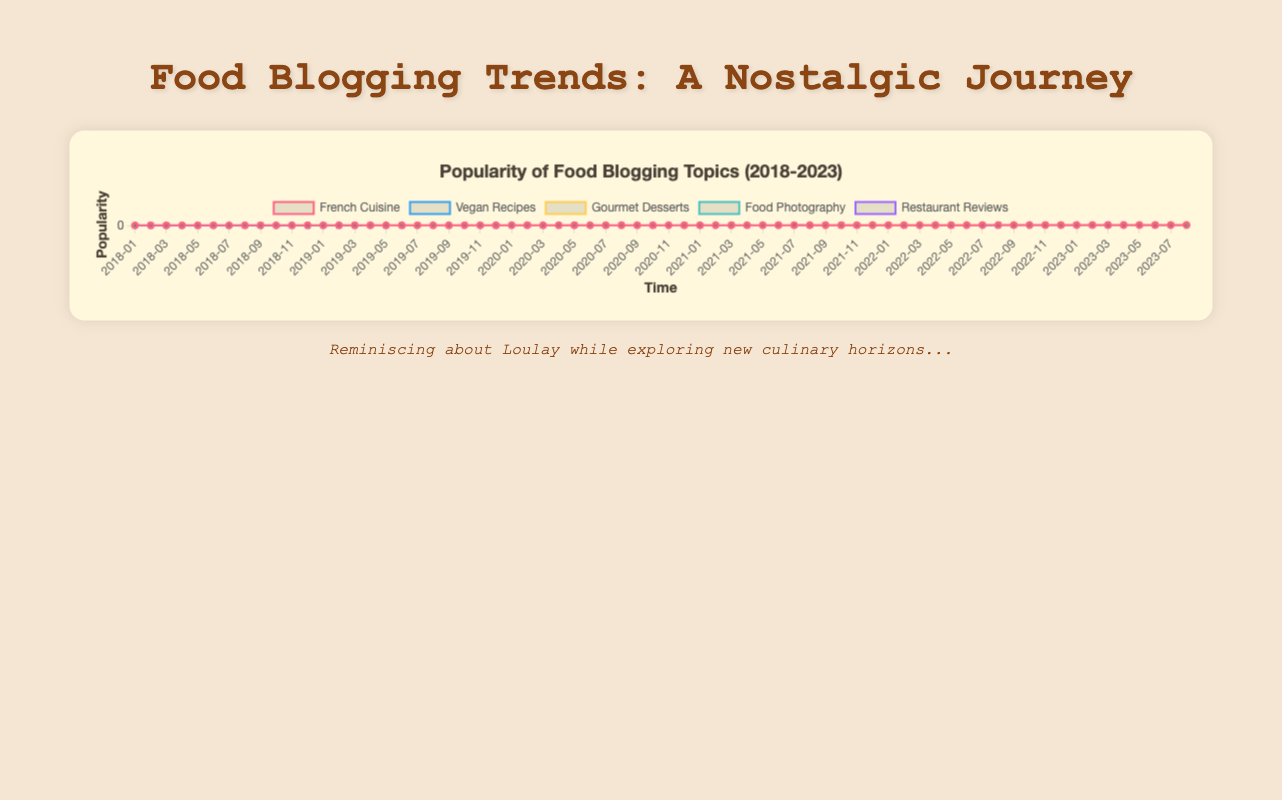What is the trend of "French Cuisine" popularity from January 2018 to August 2023? The "French Cuisine" popularity shows a general upward trend from January 2018 to August 2023. In January 2018, it starts at 45 and increases to 162 by August 2023.
Answer: Upward Which food blogging topic had the highest popularity in August 2023? In August 2023, "Restaurant Reviews" had the highest popularity with a value of 204.
Answer: Restaurant Reviews Between "Vegan Recipes" and "Gourmet Desserts," which topic had a higher surge in popularity from January 2020 to January 2021? For "Vegan Recipes," the popularity increased from 85 in January 2020 to 124 in January 2021, a difference of 39. For "Gourmet Desserts," the popularity increased from 100 in January 2020 to 128 in January 2021, a difference of 28. Therefore, "Vegan Recipes" had a higher surge.
Answer: Vegan Recipes What is the color used to represent "Food Photography" in the chart? The "Food Photography" topic is represented by a blue line in the chart.
Answer: Blue During which period did "French Cuisine" see the most significant increase in popularity? The significant increase for "French Cuisine" occurred between January 2020 (99) and December 2021 (118), where the value increased by 19.
Answer: January 2020 to December 2021 What is the average popularity of "Gourmet Desserts" in the first half of 2018? The values for "Gourmet Desserts" in the first half of 2018 are 40, 42, 45, 44, 43, and 47. Summing these, (40 + 42 + 45 + 44 + 43 + 47) = 261, and the average is 261/6 = 43.5.
Answer: 43.5 Compare the popularity of "Restaurant Reviews" and "Food Photography" in June 2020. Which one is higher and by how much? In June 2020, "Restaurant Reviews" has a popularity of 116, and "Food Photography" has 92. The difference is 116 - 92 = 24.
Answer: Restaurant Reviews by 24 What was the lowest recorded popularity for "Food Photography" over the past 5 years? "Food Photography" had its lowest recorded popularity at 20 in January 2018.
Answer: 20 